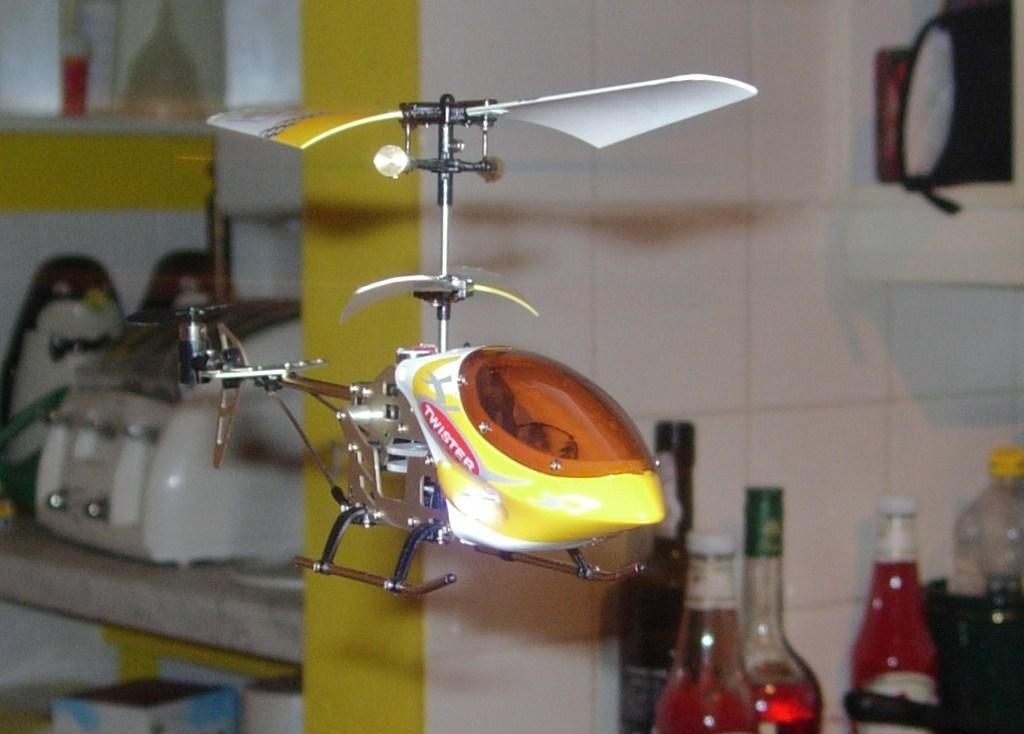Could you give a brief overview of what you see in this image? In this picture there is a toy helicopter in the center of the image and there are bottles on the right side of the image. 